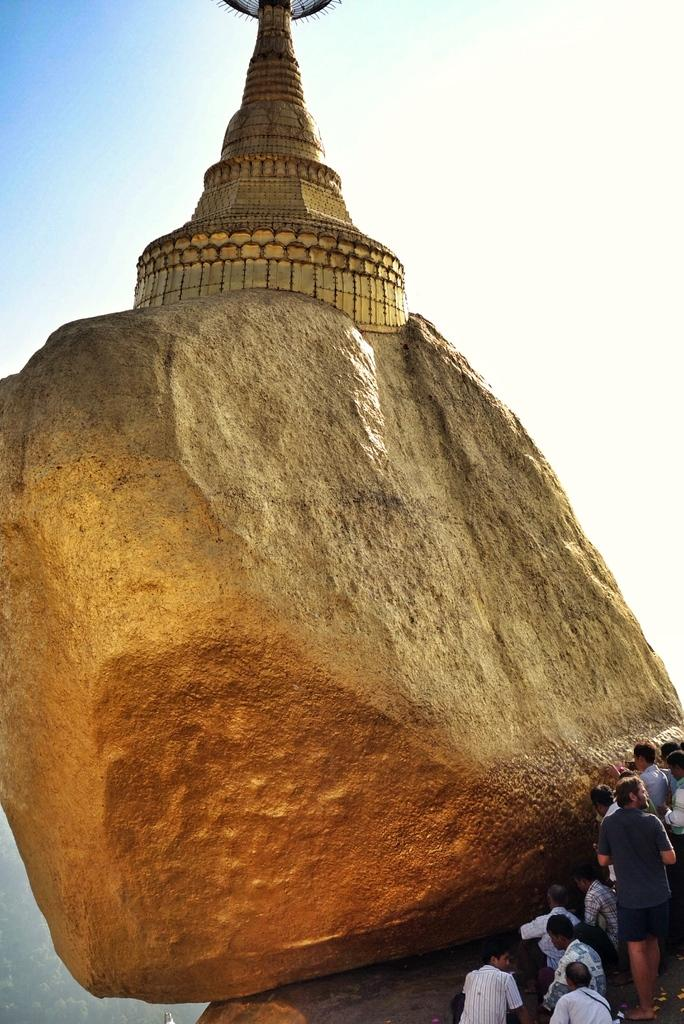What is the main structure in the image? There is a tower in the image. What is the tower standing on? The tower is on a rock. Are there any people visible in the image? Yes, there are people standing in the bottom right of the image. What can be seen at the top of the image? The sky is visible at the top of the image. What type of rifle is being used by the people in the image? There is no rifle present in the image; it only features a tower on a rock and people standing nearby. 